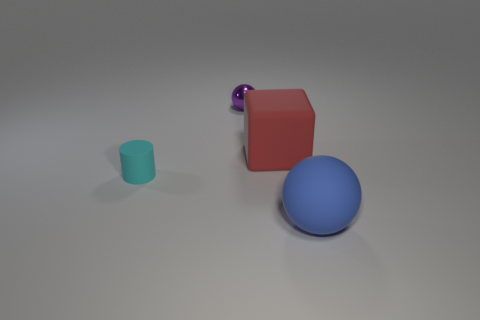Is there a small sphere that has the same material as the red block?
Your answer should be very brief. No. Does the large ball have the same material as the small cyan cylinder?
Give a very brief answer. Yes. There is another object that is the same size as the purple thing; what color is it?
Give a very brief answer. Cyan. How many other objects are the same shape as the big blue rubber thing?
Ensure brevity in your answer.  1. Do the purple metal ball and the thing in front of the tiny cyan matte cylinder have the same size?
Offer a terse response. No. How many things are large balls or purple shiny spheres?
Your answer should be very brief. 2. Do the tiny matte thing and the ball that is right of the small purple shiny object have the same color?
Ensure brevity in your answer.  No. How many cylinders are red rubber objects or cyan rubber things?
Ensure brevity in your answer.  1. Are there any other things that have the same color as the shiny ball?
Your answer should be compact. No. There is a ball that is behind the sphere that is in front of the purple metallic sphere; what is its material?
Offer a terse response. Metal. 